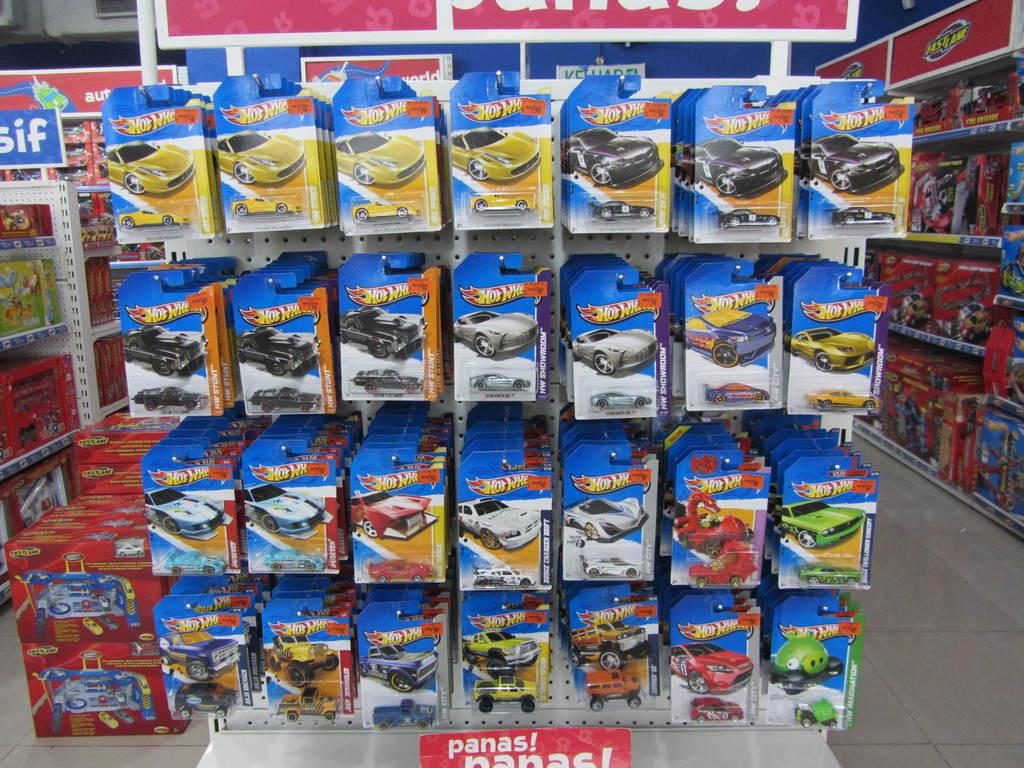<image>
Write a terse but informative summary of the picture. A display of various individually wrapped Hot Wheels cars and trucks. 